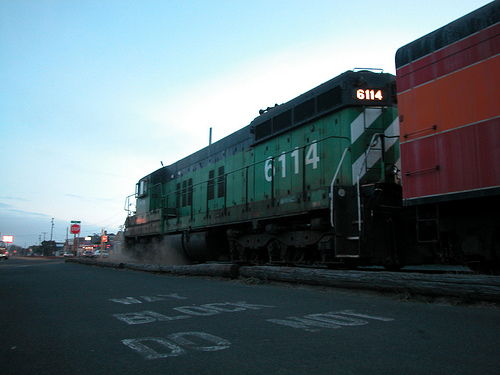Describe a long realistic scenario involving the train. The train, a key lifeline in the region, embarks on a multi-day journey transporting important goods from a coastal port to the inland towns. Laden with various freight cars, it carefully makes its way through diverse landscapes, from bustling urban centers to serene countryside stretches. Each day, the engineer maintains meticulous checks, ensuring the locomotive remains in peak condition. At various points, the train stops for scheduled maintenance and to load additional cargo. Small towns and cities count on these daily deliveries, with local businesses eagerly waiting for supplies ranging from fresh produce to industrial materials. As night falls, the train's rhythmic hum soothes the quiet surroundings, occasionally interrupted by the distant howls of nocturnal animals and the echo of its horn. Early the next morning, as the sun rises, the train approaches its final destination, where dockworkers quickly commence unloading the essential goods, ready to be distributed throughout the community, sustaining lives and livelihoods. 